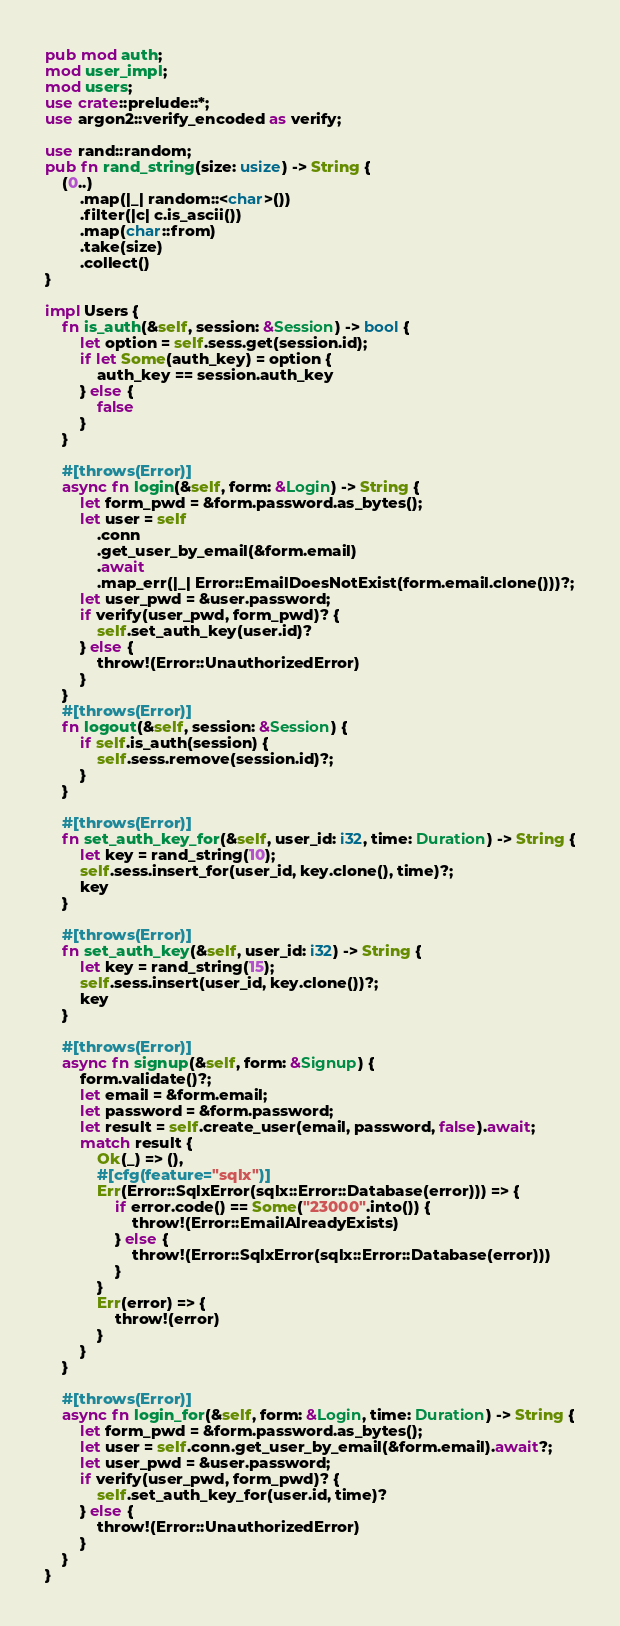Convert code to text. <code><loc_0><loc_0><loc_500><loc_500><_Rust_>pub mod auth;
mod user_impl;
mod users;
use crate::prelude::*;
use argon2::verify_encoded as verify;

use rand::random;
pub fn rand_string(size: usize) -> String {
    (0..)
        .map(|_| random::<char>())
        .filter(|c| c.is_ascii())
        .map(char::from)
        .take(size)
        .collect()
}

impl Users {
    fn is_auth(&self, session: &Session) -> bool {
        let option = self.sess.get(session.id);
        if let Some(auth_key) = option {
            auth_key == session.auth_key
        } else {
            false
        }
    }

    #[throws(Error)]
    async fn login(&self, form: &Login) -> String {
        let form_pwd = &form.password.as_bytes();
        let user = self
            .conn
            .get_user_by_email(&form.email)
            .await
            .map_err(|_| Error::EmailDoesNotExist(form.email.clone()))?;
        let user_pwd = &user.password;
        if verify(user_pwd, form_pwd)? {
            self.set_auth_key(user.id)?
        } else {
            throw!(Error::UnauthorizedError)
        }
    }
    #[throws(Error)]
    fn logout(&self, session: &Session) {
        if self.is_auth(session) {
            self.sess.remove(session.id)?;
        }
    }

    #[throws(Error)]
    fn set_auth_key_for(&self, user_id: i32, time: Duration) -> String {
        let key = rand_string(10);
        self.sess.insert_for(user_id, key.clone(), time)?;
        key
    }

    #[throws(Error)]
    fn set_auth_key(&self, user_id: i32) -> String {
        let key = rand_string(15);
        self.sess.insert(user_id, key.clone())?;
        key
    }

    #[throws(Error)]
    async fn signup(&self, form: &Signup) {
        form.validate()?;
        let email = &form.email;
        let password = &form.password;
        let result = self.create_user(email, password, false).await;
        match result {
            Ok(_) => (),
            #[cfg(feature="sqlx")]
            Err(Error::SqlxError(sqlx::Error::Database(error))) => {
                if error.code() == Some("23000".into()) {
                    throw!(Error::EmailAlreadyExists)
                } else {
                    throw!(Error::SqlxError(sqlx::Error::Database(error)))
                }
            }
            Err(error) => {
                throw!(error)
            }
        }
    }

    #[throws(Error)]
    async fn login_for(&self, form: &Login, time: Duration) -> String {
        let form_pwd = &form.password.as_bytes();
        let user = self.conn.get_user_by_email(&form.email).await?;
        let user_pwd = &user.password;
        if verify(user_pwd, form_pwd)? {
            self.set_auth_key_for(user.id, time)?
        } else {
            throw!(Error::UnauthorizedError)
        }
    }
}
</code> 